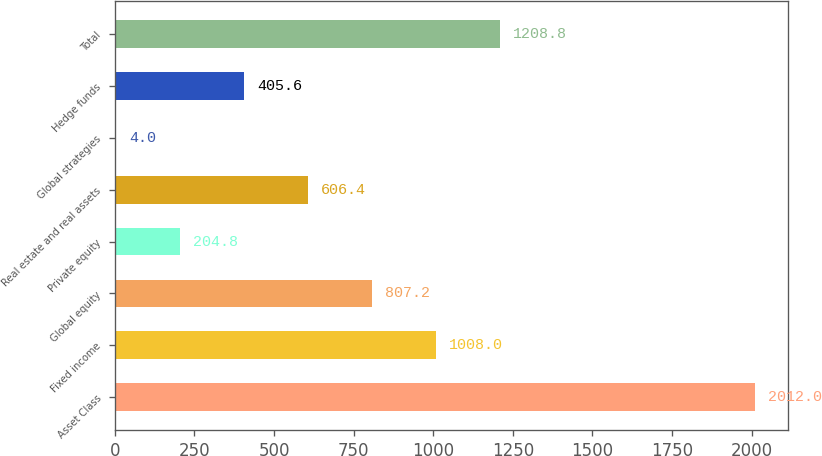Convert chart. <chart><loc_0><loc_0><loc_500><loc_500><bar_chart><fcel>Asset Class<fcel>Fixed income<fcel>Global equity<fcel>Private equity<fcel>Real estate and real assets<fcel>Global strategies<fcel>Hedge funds<fcel>Total<nl><fcel>2012<fcel>1008<fcel>807.2<fcel>204.8<fcel>606.4<fcel>4<fcel>405.6<fcel>1208.8<nl></chart> 